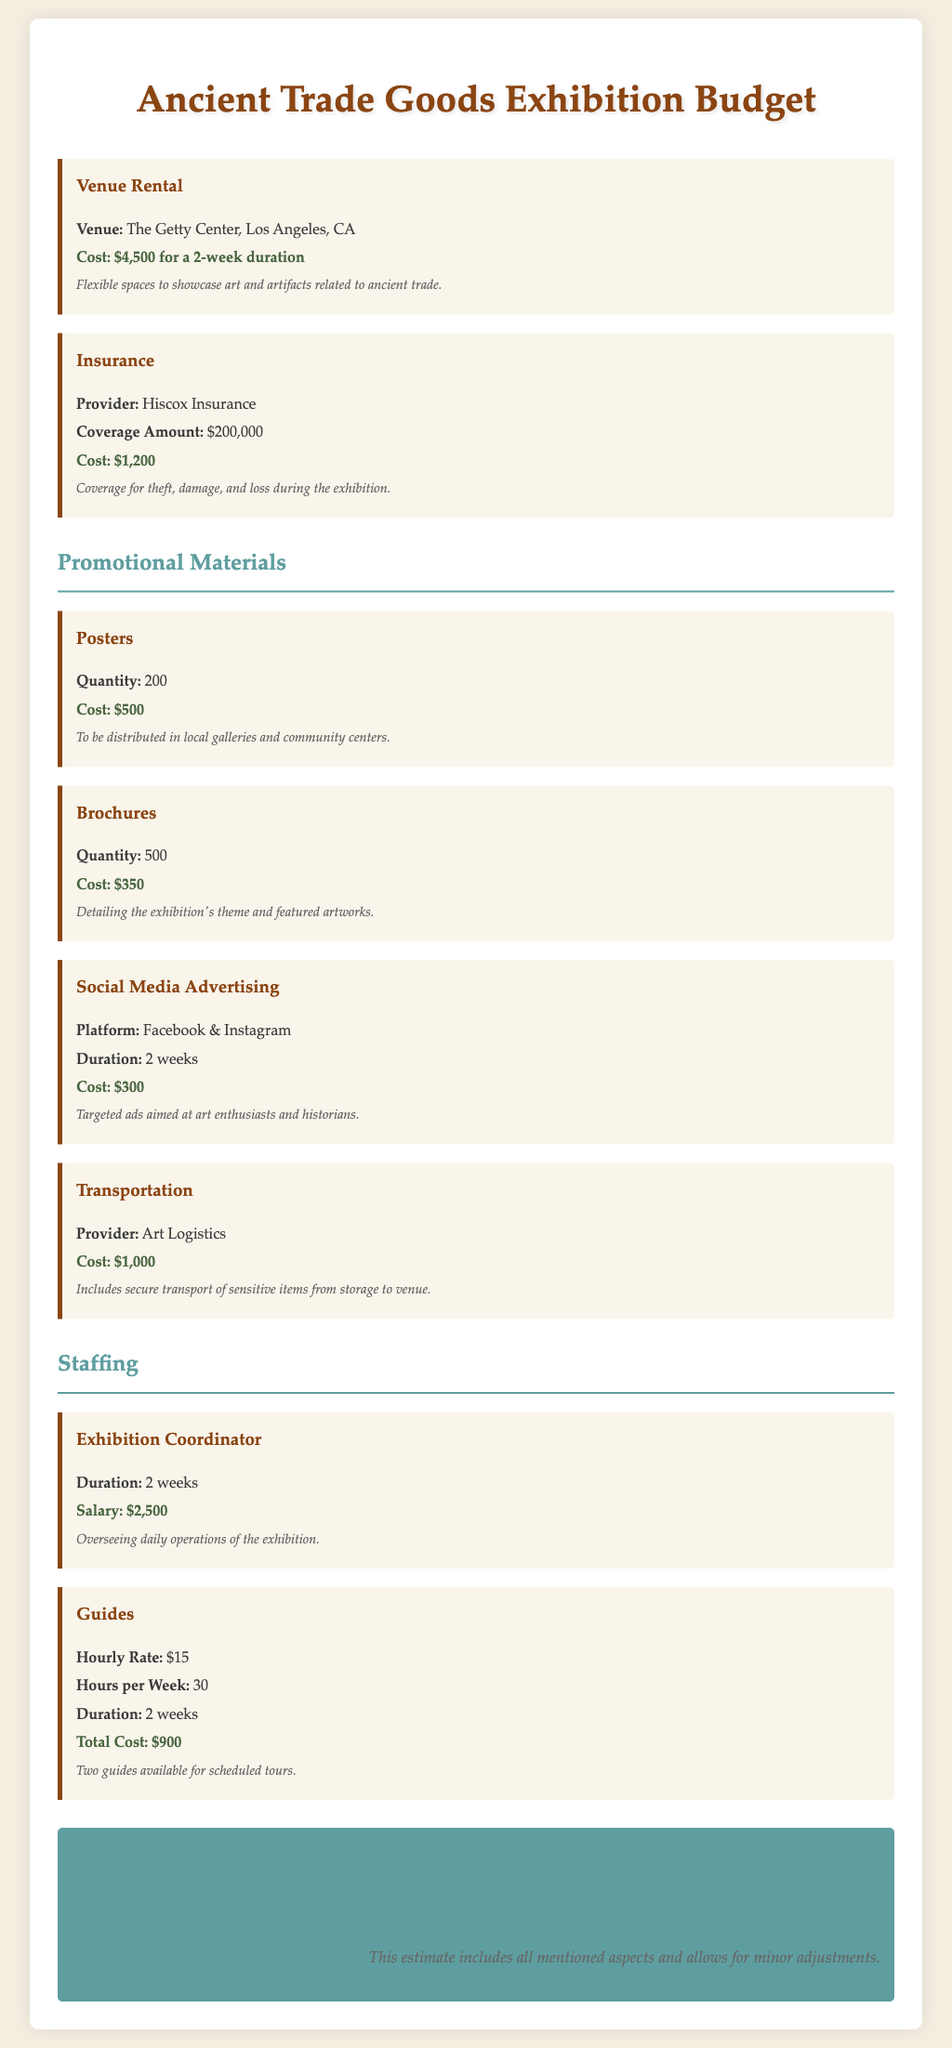What is the total estimated budget for the exhibition? The total estimated budget is given in the document as the final budget figure that includes all mentioned aspects.
Answer: $12,500 What is the cost of venue rental? The venue rental cost is specified as the price for the 2-week duration at the chosen venue.
Answer: $4,500 How much does the insurance coverage cost? The document details the cost related to the insurance provider and the amount of coverage provided.
Answer: $1,200 Who is the provider for transportation services? The document lists the service provider responsible for transporting the artworks securely.
Answer: Art Logistics How many brochures are planned for distribution? The document specifies the quantity of brochures needed for the exhibition promotion.
Answer: 500 What is the hourly rate for the guides? The document provides the payment rate for the guides who will conduct tours at the exhibition.
Answer: $15 What is the theme covered in the brochures? The brochures are meant to provide detailed information about the exhibition's concept and its featured artworks.
Answer: Theme and featured artworks What type of advertising is included in the promotional materials? The document specifies the kinds of advertising methods used to promote the exhibition, including specific platforms.
Answer: Social Media Advertising What is the duration of the insurance coverage? The document does not specify a duration but mentions the coverage amount, detailing the coverage for the event period.
Answer: Not specified What is the total cost attributed to the guides? The total cost for guides is calculated based on the hourly rate and total hours worked over the exhibition duration.
Answer: $900 